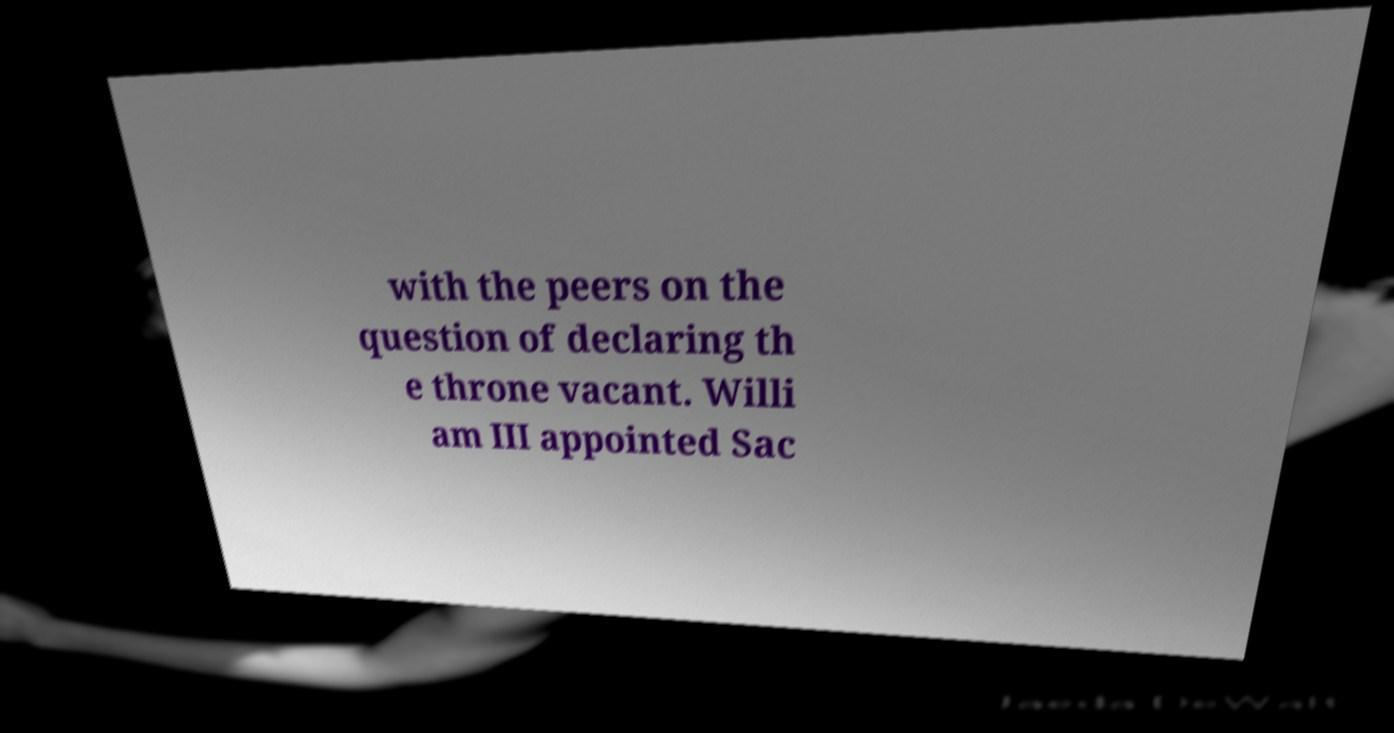I need the written content from this picture converted into text. Can you do that? with the peers on the question of declaring th e throne vacant. Willi am III appointed Sac 